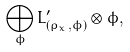Convert formula to latex. <formula><loc_0><loc_0><loc_500><loc_500>\bigoplus _ { \phi } L _ { ( \rho _ { x } , \phi ) } ^ { \prime } \otimes \phi ,</formula> 